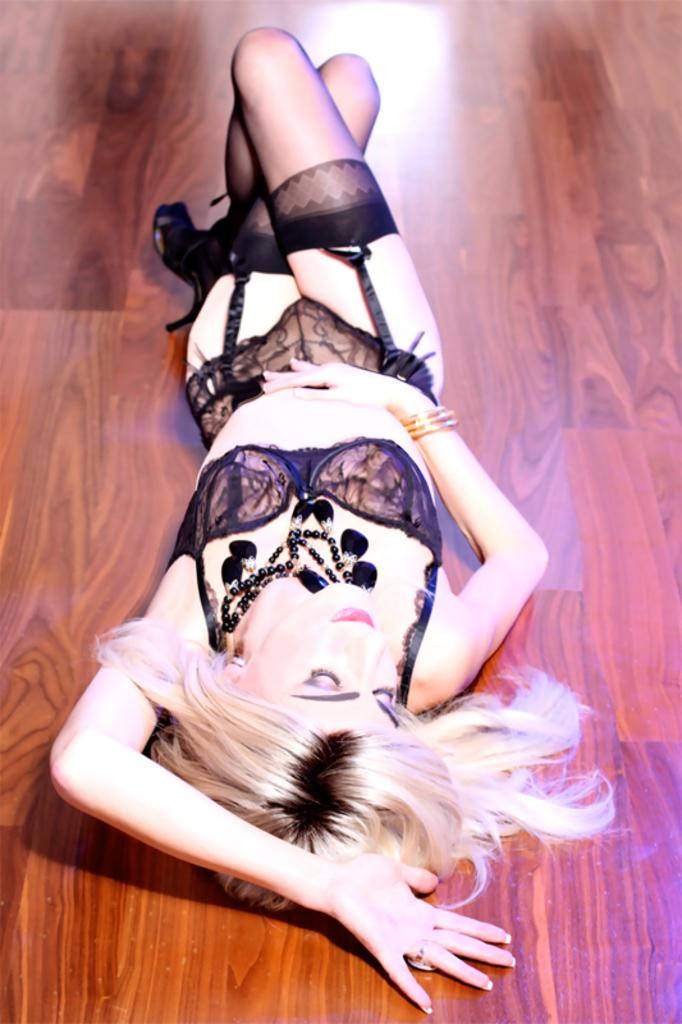Who is the main subject in the image? There is a lady in the image. What is the lady doing in the image? The lady is lying on the floor. What type of park can be seen in the background of the image? There is no park visible in the image; it only features a lady lying on the floor. What kind of apparel is the lady wearing in the image? The provided facts do not mention any specific apparel the lady is wearing. 